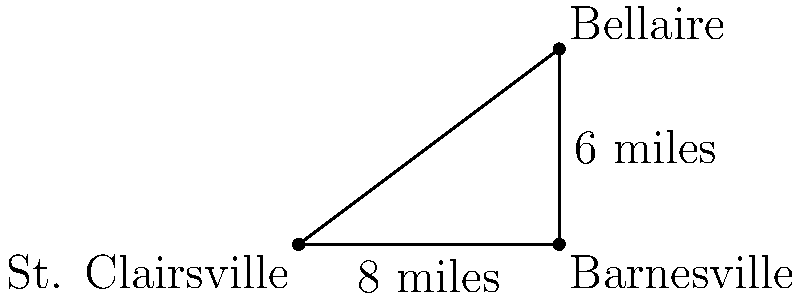You're planning a social event tour across Belmont County, Ohio. Starting from St. Clairsville, you want to visit Barnesville and Bellaire. You know that Barnesville is 8 miles east of St. Clairsville, and Bellaire is 6 miles north of Barnesville. Using the Pythagorean theorem, calculate the direct distance between St. Clairsville and Bellaire to optimize your travel route. To solve this problem, we can use the Pythagorean theorem:

1. Let's consider the triangle formed by St. Clairsville, Barnesville, and Bellaire:
   - St. Clairsville to Barnesville: 8 miles (east)
   - Barnesville to Bellaire: 6 miles (north)
   - St. Clairsville to Bellaire: unknown (to be calculated)

2. The Pythagorean theorem states that in a right triangle, $a^2 + b^2 = c^2$, where c is the hypotenuse (longest side).

3. In our case:
   $a = 8$ miles (St. Clairsville to Barnesville)
   $b = 6$ miles (Barnesville to Bellaire)
   $c =$ the distance we want to find (St. Clairsville to Bellaire)

4. Let's apply the Pythagorean theorem:
   $c^2 = a^2 + b^2$
   $c^2 = 8^2 + 6^2$
   $c^2 = 64 + 36$
   $c^2 = 100$

5. To find c, we take the square root of both sides:
   $c = \sqrt{100}$
   $c = 10$

Therefore, the direct distance between St. Clairsville and Bellaire is 10 miles.
Answer: 10 miles 